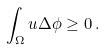Convert formula to latex. <formula><loc_0><loc_0><loc_500><loc_500>\int _ { \Omega } u \Delta \phi \geq 0 \, .</formula> 